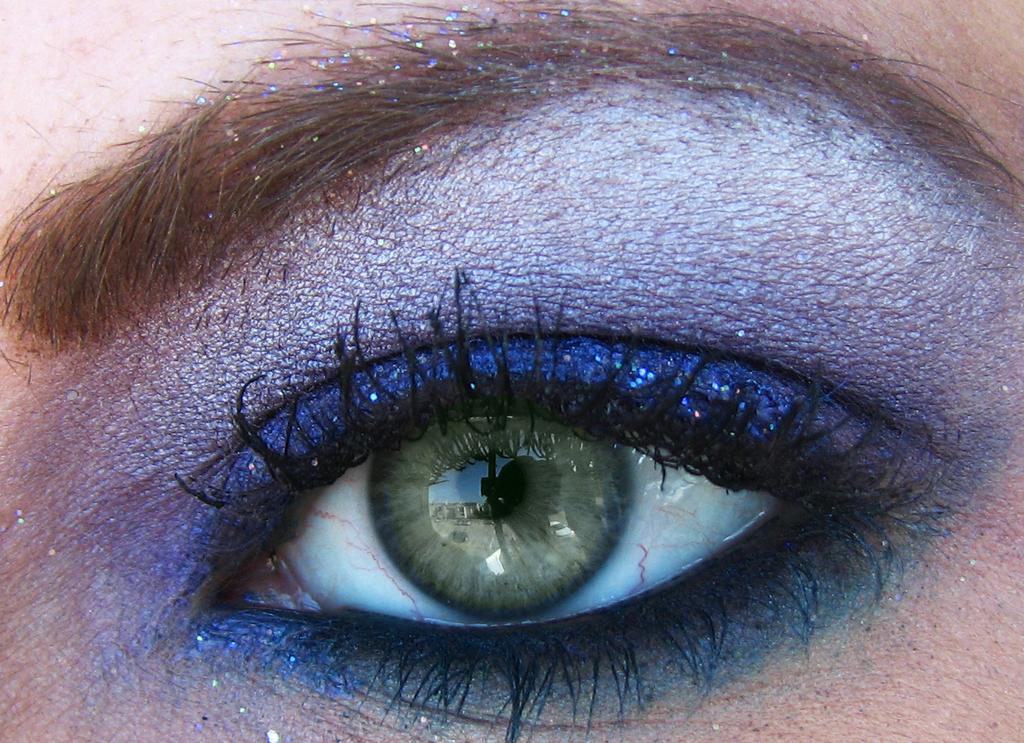What is the main subject of the image? The main subject of the image is the eye of a person. Can you describe any makeup applied to the eye? Yes, there is eyeshadow applied to the eye. What type of calculator is being used by the chickens in the image? There are no chickens or calculators present in the image; it features the eye of a person with eyeshadow applied. 